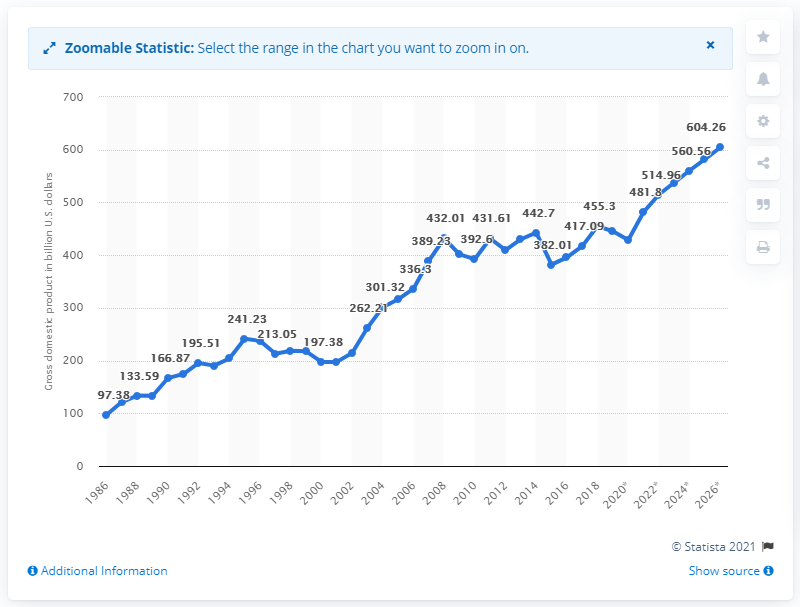Draw attention to some important aspects in this diagram. In 2019, the Gross Domestic Product (GDP) of Austria was estimated to be 445.13 billion US dollars. 